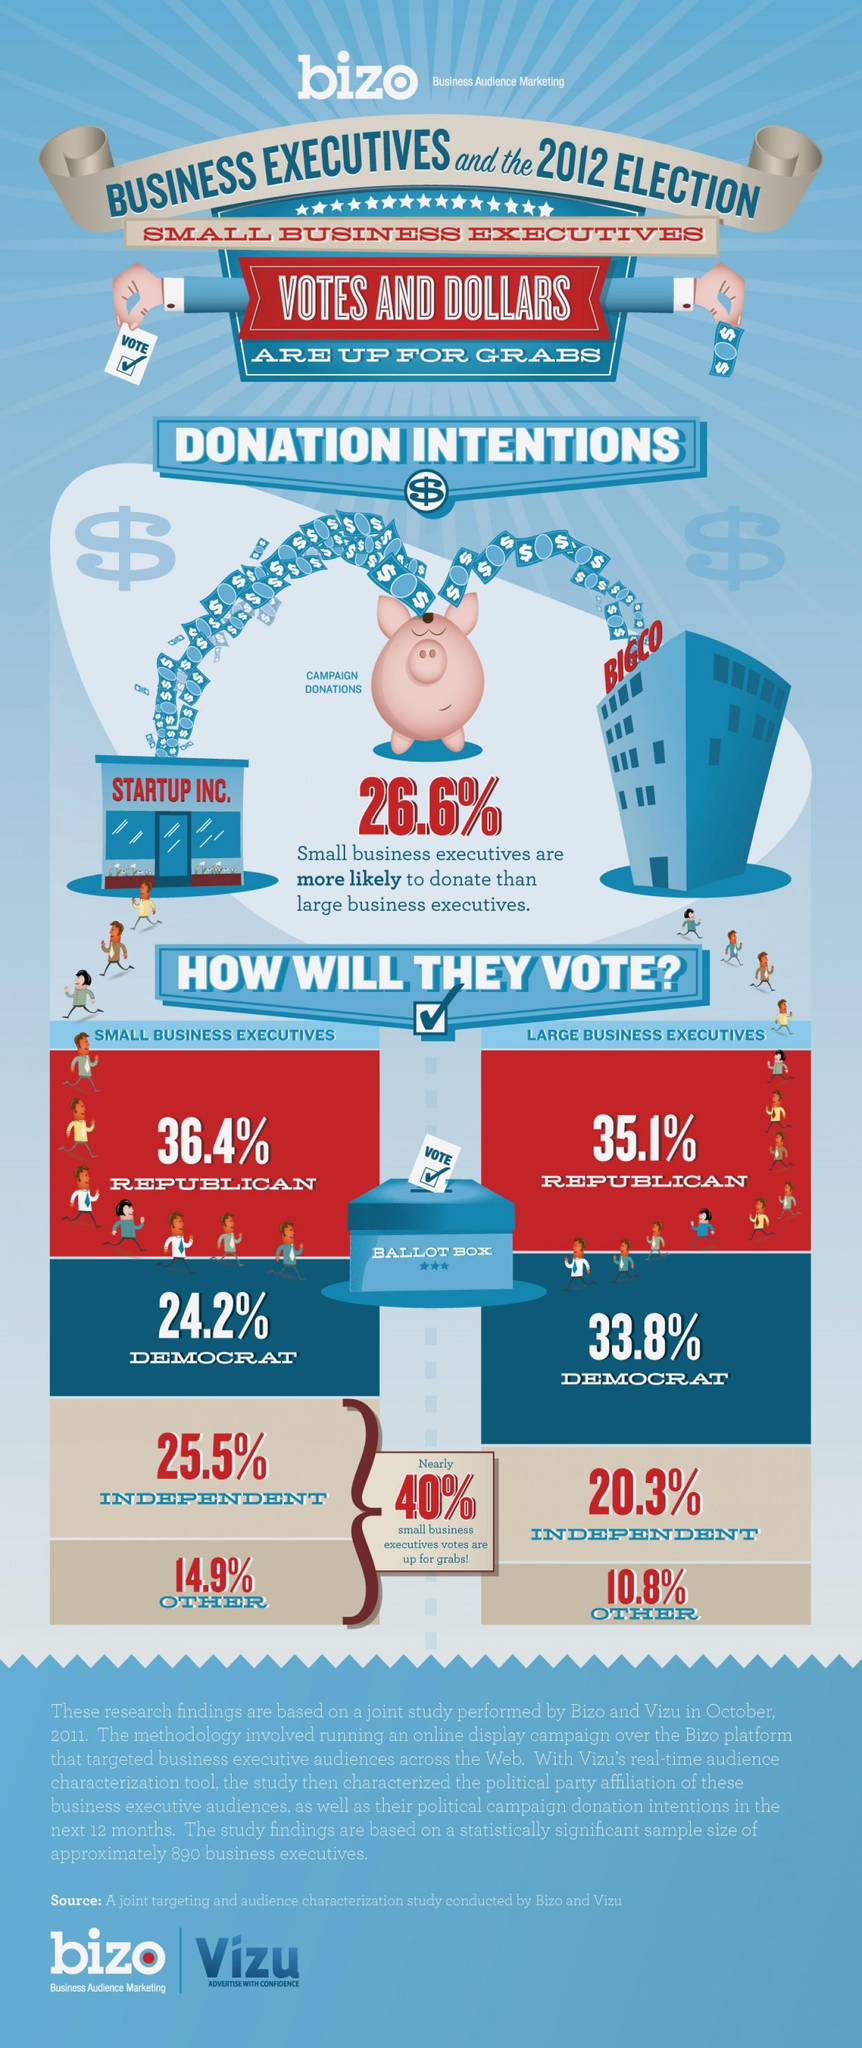Indicate a few pertinent items in this graphic. According to a study performed by Bizo & Vizu in October 2011, 25.5% of small business executives planned to vote for the independent party in the 2012 US election. A study conducted by Bizo & Vizu in October 2011 found that 24.2% of small business executives in the United States planned to vote for the Democratic Party in the 2012 election. According to a study performed by Bizo & Vizu in October 2011, the majority of large business executives in the US voted for the Republican party in the 2012 election. 